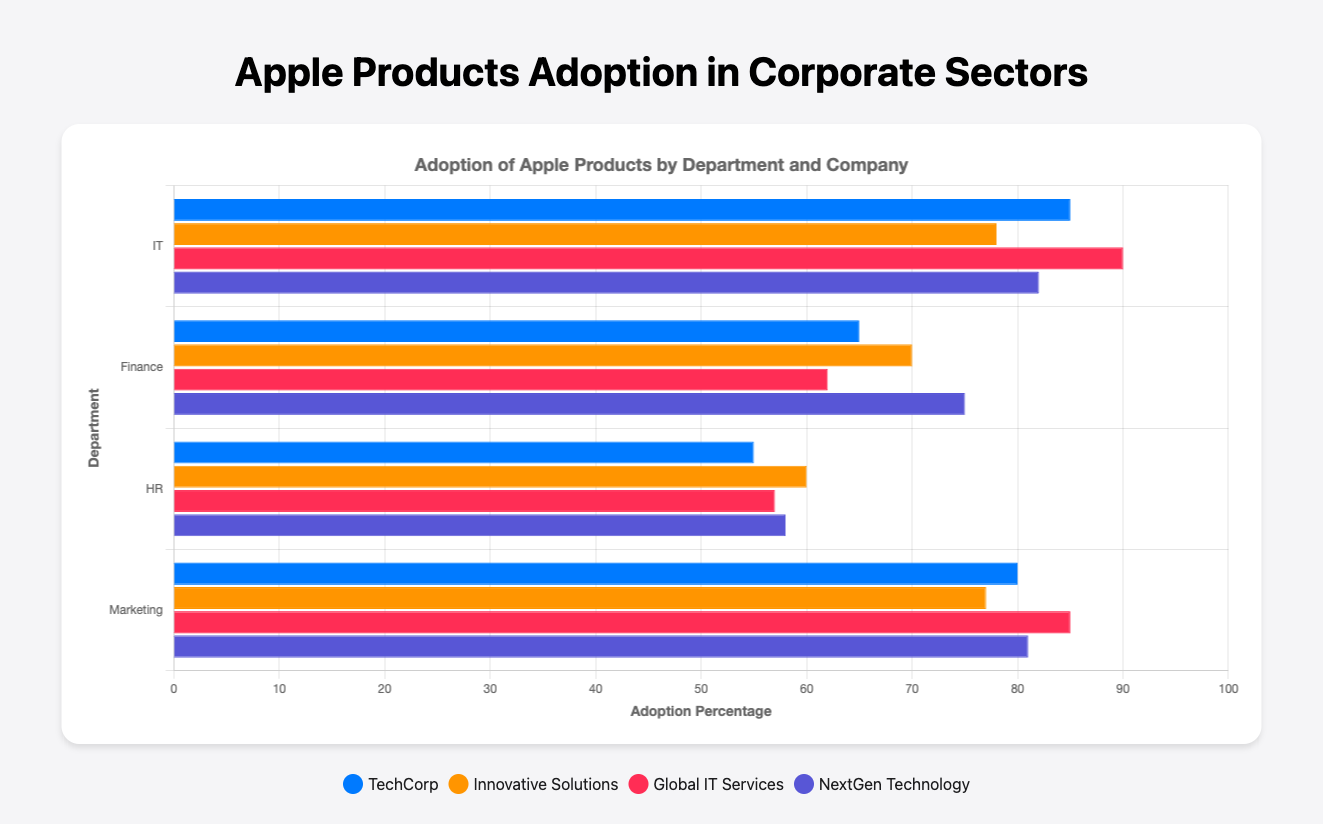What are the adoption percentages for HR Innovations in all departments? HR Innovations has an adoption percentage in the HR department, but not in others, so it is only represented by one bar at 57%.
Answer: 57% Which company in the IT department has the highest adoption percentage? By comparing the bar heights in the IT department, Global IT Services has the tallest bar with an adoption percentage of 90%.
Answer: Global IT Services Compare the adoption percentage of Global Marketing Co and Global Finance Group. Which is higher? Global Marketing Co's adoption percentage in the Marketing department is 85%, and Global Finance Group's adoption percentage in the Finance department is 75%. The adoption percentage of Global Marketing Co is higher.
Answer: Global Marketing Co What is the average adoption percentage of companies in the Finance department? Summing the adoption percentages of companies in the Finance department (65 + 70 + 62 + 75) gives 272. Dividing this by 4 (number of companies) gives an average of 68%.
Answer: 68% Which department has the lowest average adoption of Apple products? The average adoption percentages for each department need to be calculated and compared. HR department: (55 + 60 + 57 + 58) / 4 = 57.5%, Finance: 68%, IT: (85 + 78 + 90 + 82) / 4 = 83.75%, Marketing: (80 + 77 + 85 + 81) / 4 = 80.75%. The HR department has the lowest average adoption percentage.
Answer: HR What is the difference in adoption percentage between TechCorp and NextGen Technology? TechCorp's adoption percentage is 85%, and NextGen Technology's is 82%. The difference is 85% - 82% = 3%.
Answer: 3% Which company has the highest adoption percentage across all departments? By comparing the bar heights/values of all companies across all departments, Global IT Services in the IT department has the highest adoption percentage of 90%.
Answer: Global IT Services What are the median adoption percentages for the Finance and Marketing departments? For the Finance department, the percentages are ordered: 62, 65, 70, 75. The median is the average of the two middle values: (65 + 70) / 2 = 67.5. For the Marketing department, the values are ordered: 77, 80, 81, 85. The median is the average of the two middle values: (80 + 81) / 2 = 80.5.
Answer: Finance: 67.5, Marketing: 80.5 How many departments have at least one company with an adoption percentage above 80%? IT department has TechCorp, Global IT Services, and NextGen Technology above 80%. Marketing has MarketGurus, Global Marketing Co, and NextWave Marketing above 80%. Finance and HR departments do not have any companies above 80%. Thus, 2 departments have companies with adoption percentages above 80%.
Answer: 2 